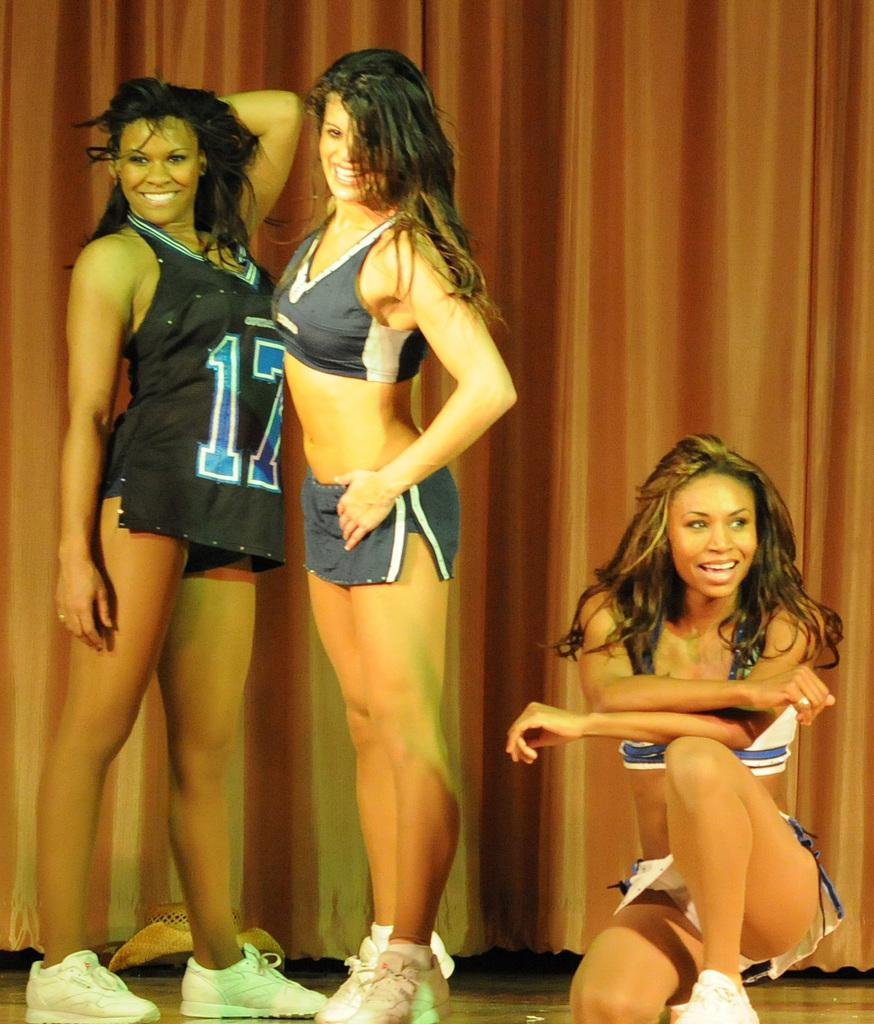<image>
Render a clear and concise summary of the photo. three ladies and one with the number 17 on them 